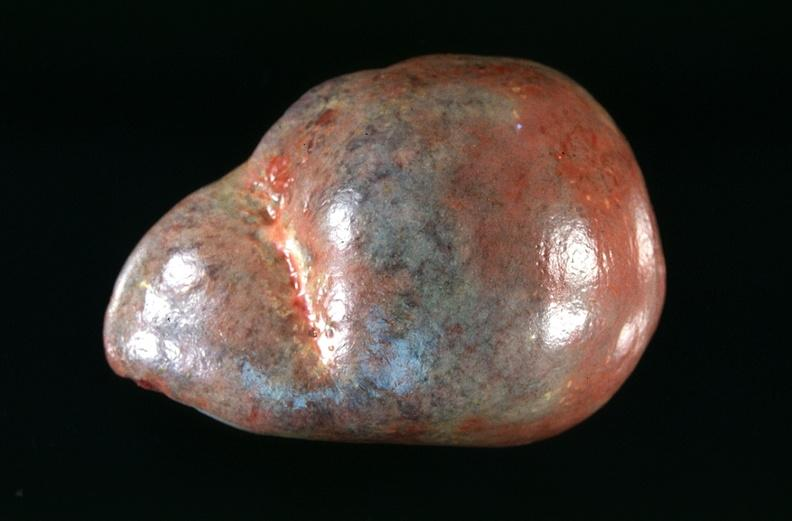what is present?
Answer the question using a single word or phrase. Hematologic 